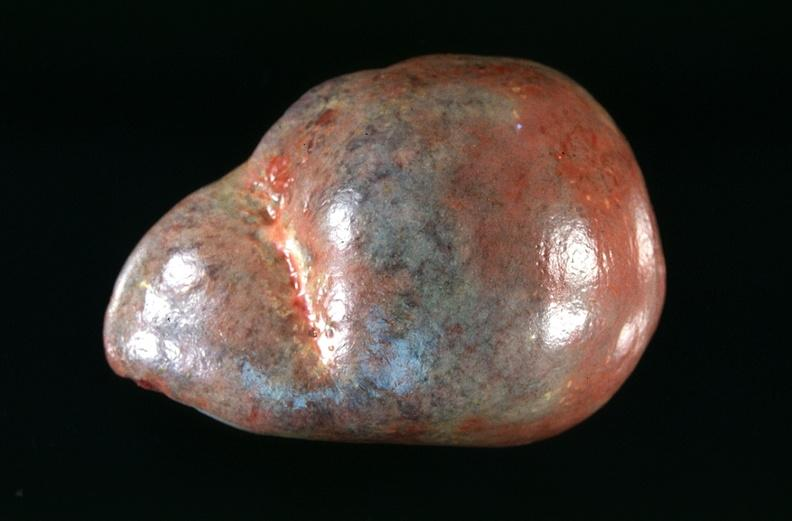what is present?
Answer the question using a single word or phrase. Hematologic 